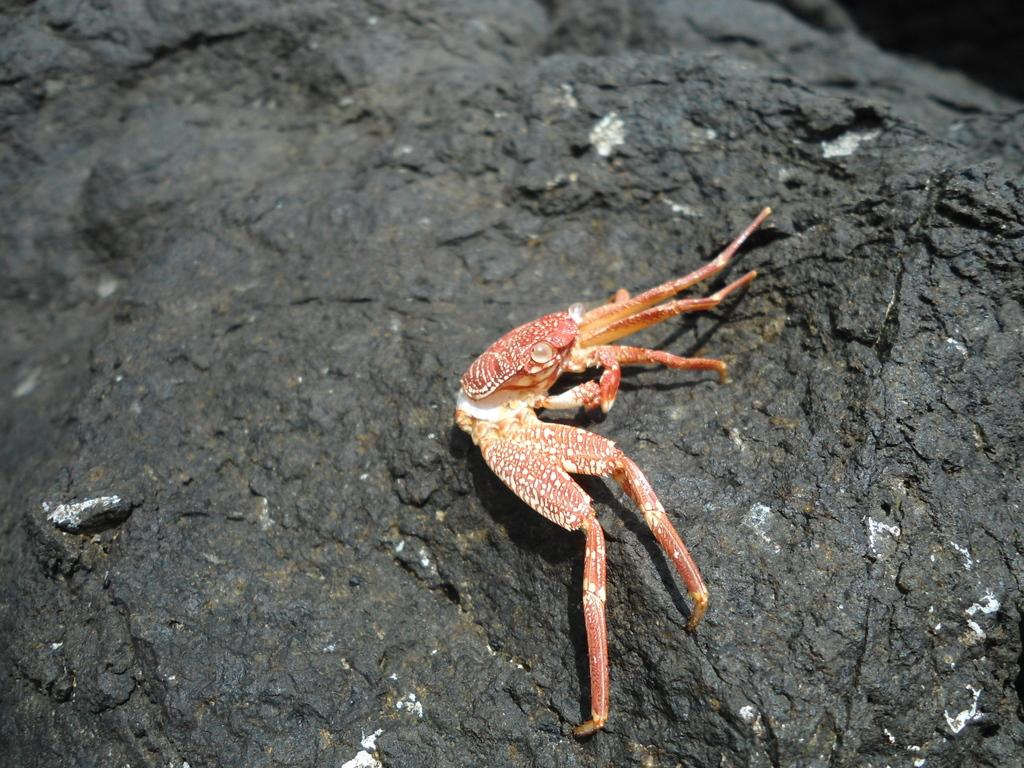What type of animal is in the image? There is a crab in the image. Where is the crab located in the image? The crab is on the surface. What type of goat can be seen grazing in the image? There is no goat present in the image; it features a crab on the surface. How much sugar is visible in the image? There is no sugar present in the image. 